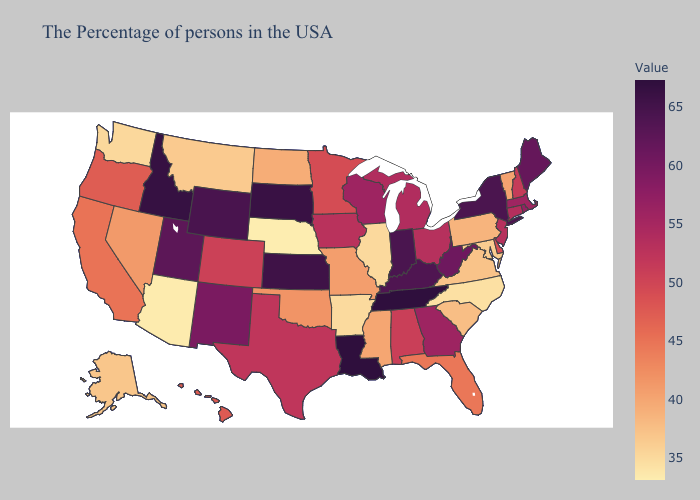Does New York have the highest value in the Northeast?
Be succinct. Yes. Which states hav the highest value in the South?
Keep it brief. Tennessee, Louisiana. Which states have the lowest value in the Northeast?
Keep it brief. Pennsylvania. Which states have the lowest value in the USA?
Be succinct. Nebraska. Which states have the lowest value in the USA?
Keep it brief. Nebraska. 